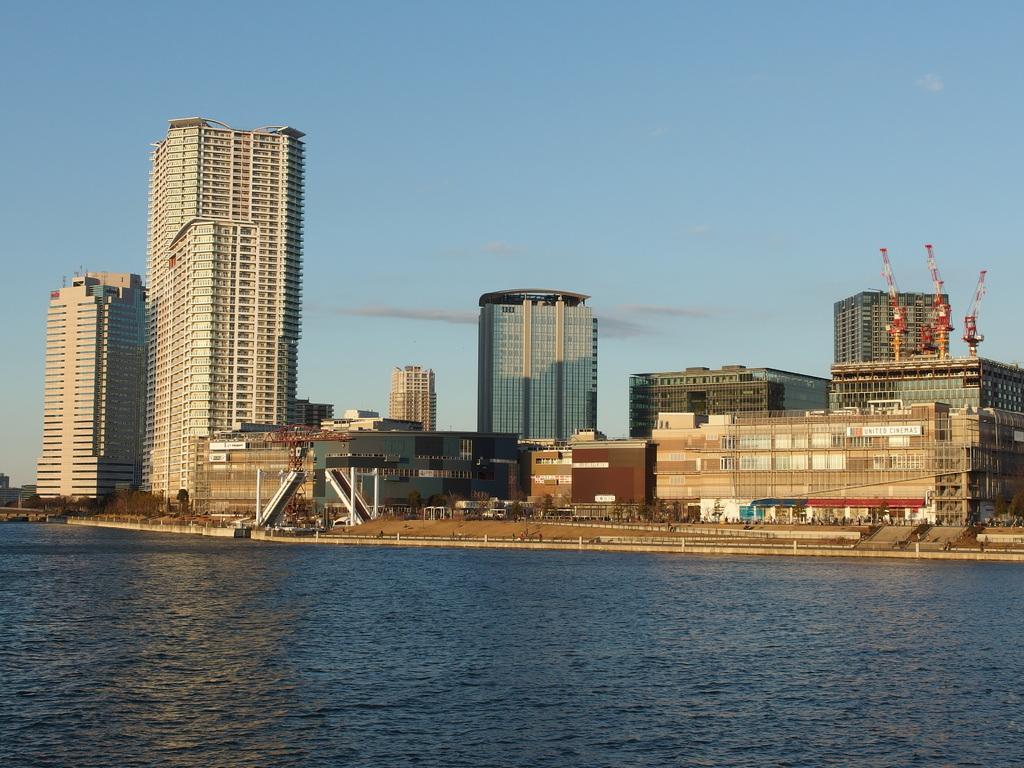In one or two sentences, can you explain what this image depicts? In the foreground of this image, there is water. In the background, there are buildings, trees and cranes on the building, sky and the cloud. 